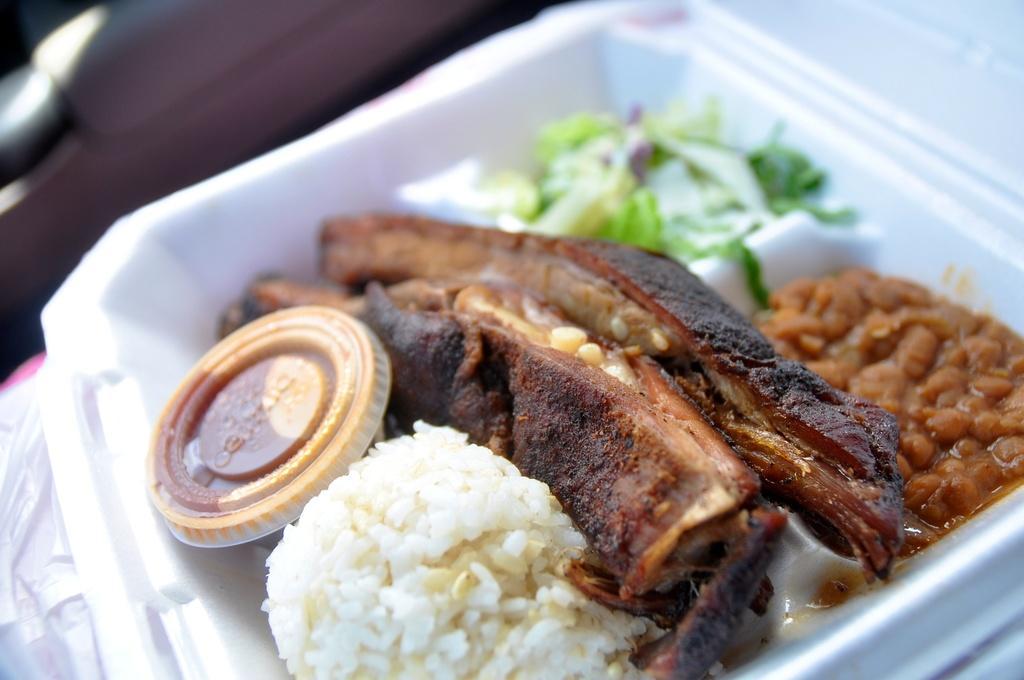Please provide a concise description of this image. In this image I can see the food items in white color box. Food is in brown, black, green and white color. Background is blurred. 